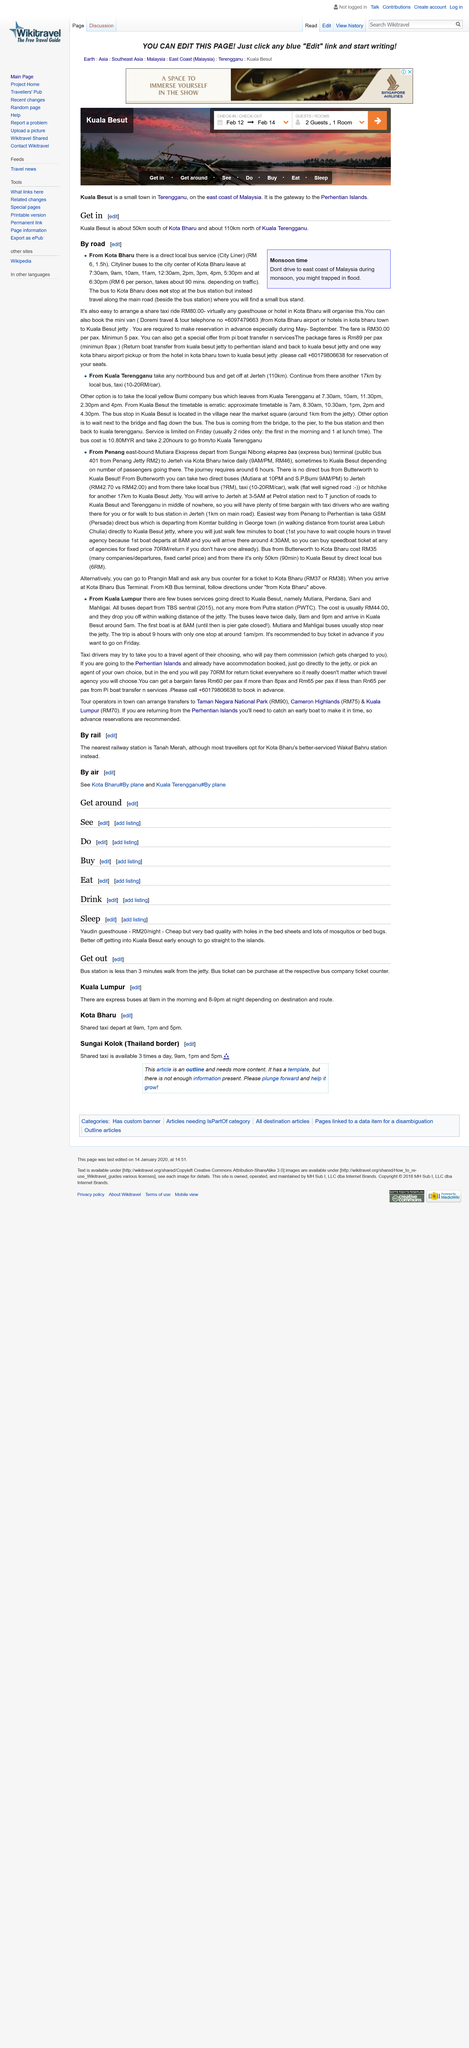Highlight a few significant elements in this photo. How far is Kuala Besut from Kota Bharu in kilometers? There are 96 kilometers between Kuala Besut and Kota Bharu. Do not drive to the east coast of Malaysia during the monsoon season. The duration of a bus journey to the city center of Kota Bharu may vary depending on traffic conditions, typically ranging from 90 to minutes. 